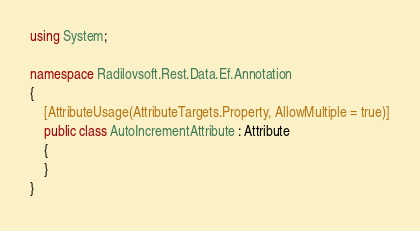Convert code to text. <code><loc_0><loc_0><loc_500><loc_500><_C#_>using System;

namespace Radilovsoft.Rest.Data.Ef.Annotation
{
    [AttributeUsage(AttributeTargets.Property, AllowMultiple = true)]
    public class AutoIncrementAttribute : Attribute
    {
    }
}</code> 